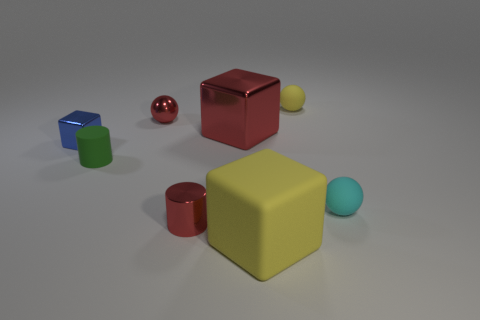There is a small rubber thing that is on the left side of the tiny red ball; does it have the same color as the tiny shiny ball?
Provide a short and direct response. No. There is a cylinder that is in front of the green cylinder; what is its size?
Provide a succinct answer. Small. What is the shape of the tiny matte object left of the yellow thing that is in front of the rubber cylinder?
Ensure brevity in your answer.  Cylinder. What is the color of the other shiny object that is the same shape as the small green thing?
Your answer should be very brief. Red. Does the yellow matte object to the left of the yellow rubber sphere have the same size as the small red cylinder?
Offer a terse response. No. The tiny thing that is the same color as the metallic cylinder is what shape?
Provide a short and direct response. Sphere. How many red things are the same material as the tiny cyan ball?
Your answer should be compact. 0. The big block that is behind the small cylinder that is to the left of the tiny red metal object in front of the green cylinder is made of what material?
Provide a short and direct response. Metal. There is a tiny matte thing left of the big yellow thing in front of the cyan sphere; what color is it?
Keep it short and to the point. Green. What is the color of the cube that is the same size as the green rubber cylinder?
Make the answer very short. Blue. 